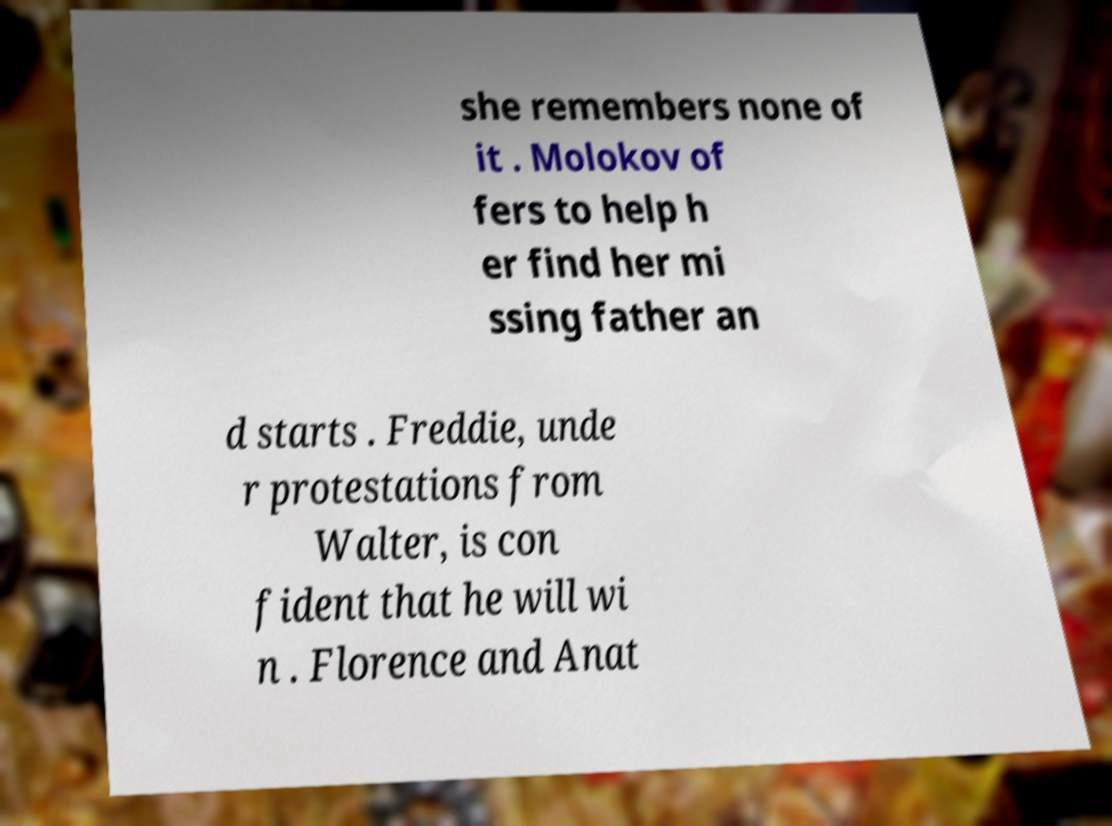For documentation purposes, I need the text within this image transcribed. Could you provide that? she remembers none of it . Molokov of fers to help h er find her mi ssing father an d starts . Freddie, unde r protestations from Walter, is con fident that he will wi n . Florence and Anat 